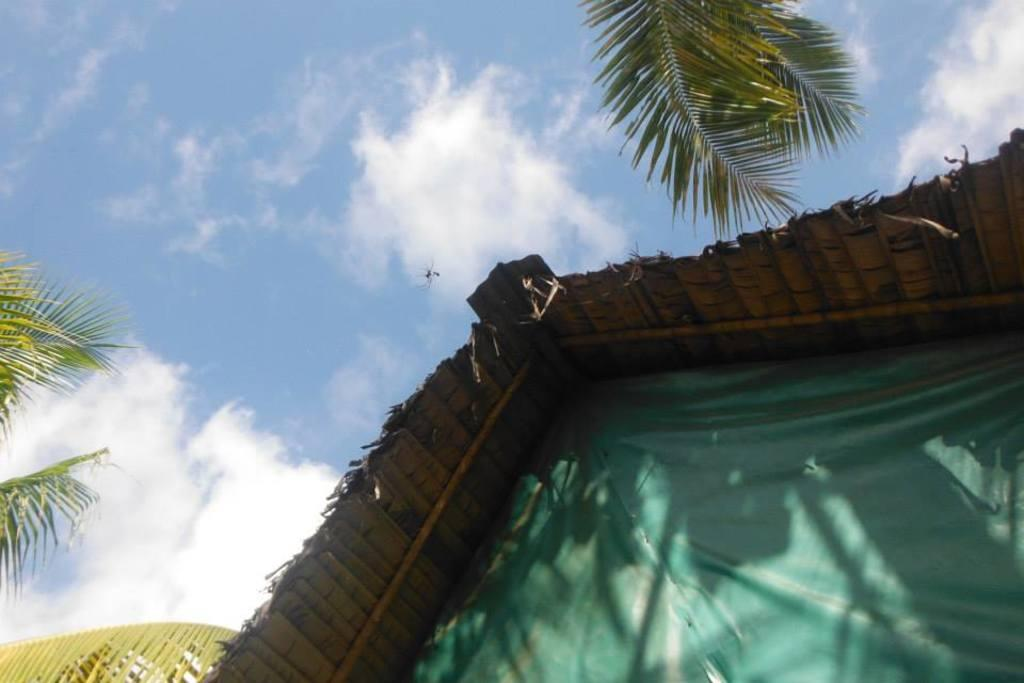What is the main structure in the foreground of the image? There is a tent house in the foreground of the image. What can be seen in the background of the image? The sky is visible in the background of the image. How many cows are attacking the tent house in the image? There are no cows present in the image, and therefore no attack is taking place. 